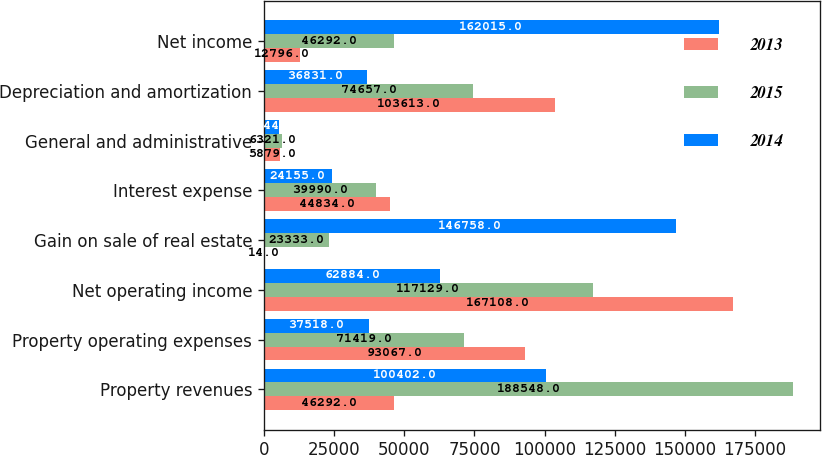Convert chart to OTSL. <chart><loc_0><loc_0><loc_500><loc_500><stacked_bar_chart><ecel><fcel>Property revenues<fcel>Property operating expenses<fcel>Net operating income<fcel>Gain on sale of real estate<fcel>Interest expense<fcel>General and administrative<fcel>Depreciation and amortization<fcel>Net income<nl><fcel>2013<fcel>46292<fcel>93067<fcel>167108<fcel>14<fcel>44834<fcel>5879<fcel>103613<fcel>12796<nl><fcel>2015<fcel>188548<fcel>71419<fcel>117129<fcel>23333<fcel>39990<fcel>6321<fcel>74657<fcel>46292<nl><fcel>2014<fcel>100402<fcel>37518<fcel>62884<fcel>146758<fcel>24155<fcel>5344<fcel>36831<fcel>162015<nl></chart> 